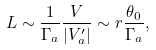Convert formula to latex. <formula><loc_0><loc_0><loc_500><loc_500>L \sim \frac { 1 } { \Gamma _ { a } } \frac { V } { | V ^ { \prime } _ { a } | } \sim r \frac { \theta _ { 0 } } { \Gamma _ { a } } ,</formula> 